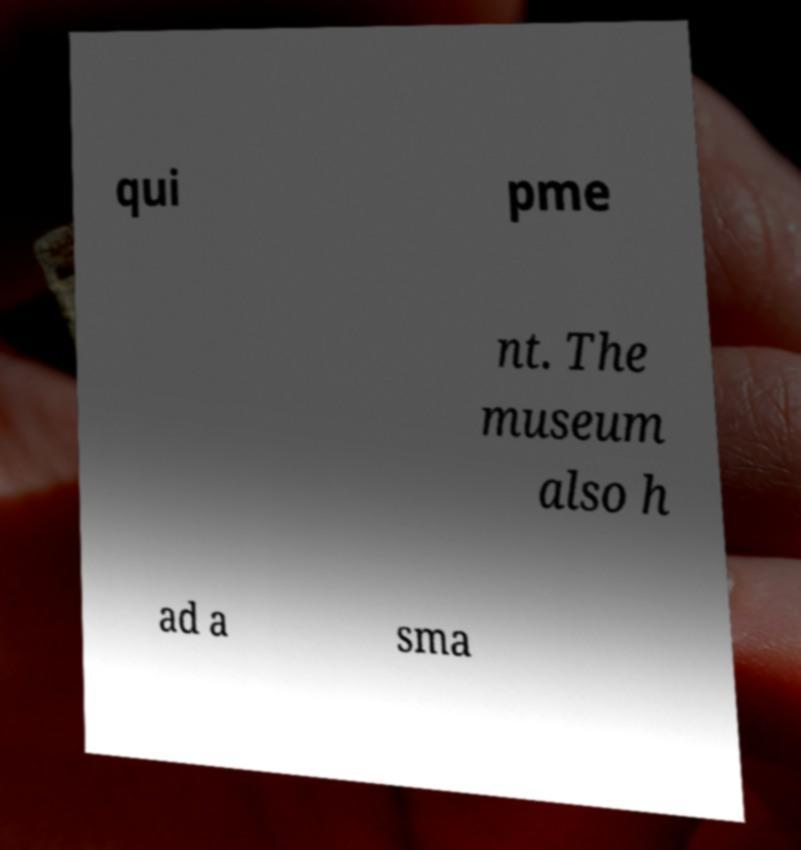Can you read and provide the text displayed in the image?This photo seems to have some interesting text. Can you extract and type it out for me? qui pme nt. The museum also h ad a sma 